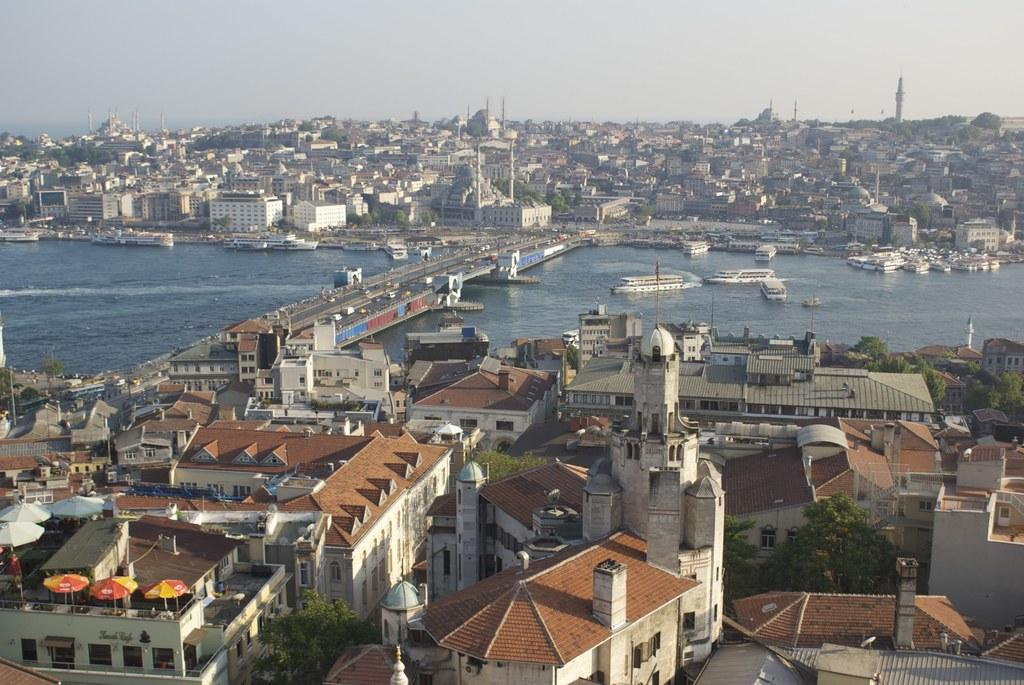What can be seen in the foreground area of the image? There are buildings and trees in the foreground area of the image. What is located on the water surface in the image? There are ships on the water surface. What is visible in the background of the image? There is a bridge, buildings, and the sky visible in the background of the image. How many fans are visible in the image? There are no fans present in the image. What type of fork can be seen in the image? There is no fork present in the image. 